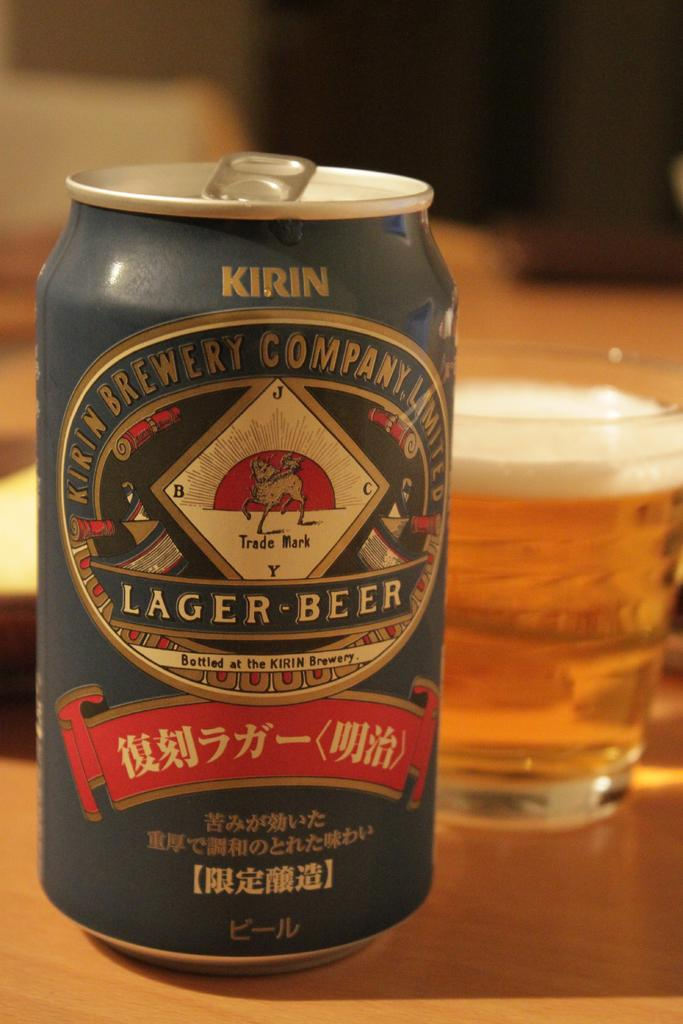<image>
Give a short and clear explanation of the subsequent image. A can of Kirin Lager Beer sits next to a glass full of beer. 